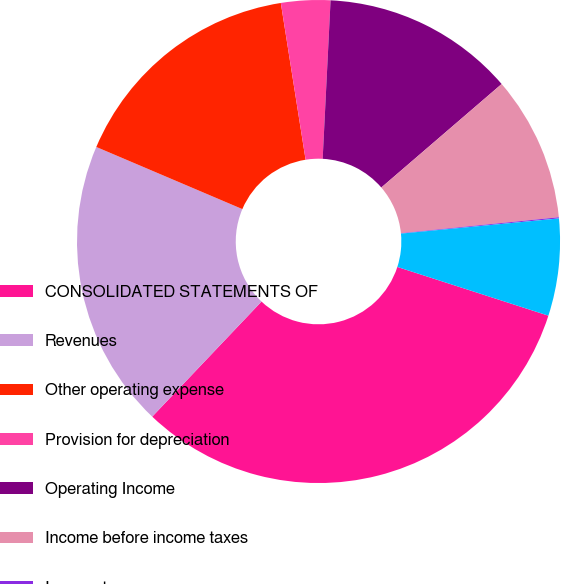<chart> <loc_0><loc_0><loc_500><loc_500><pie_chart><fcel>CONSOLIDATED STATEMENTS OF<fcel>Revenues<fcel>Other operating expense<fcel>Provision for depreciation<fcel>Operating Income<fcel>Income before income taxes<fcel>Income taxes<fcel>Net Income<nl><fcel>32.12%<fcel>19.31%<fcel>16.1%<fcel>3.29%<fcel>12.9%<fcel>9.7%<fcel>0.08%<fcel>6.49%<nl></chart> 